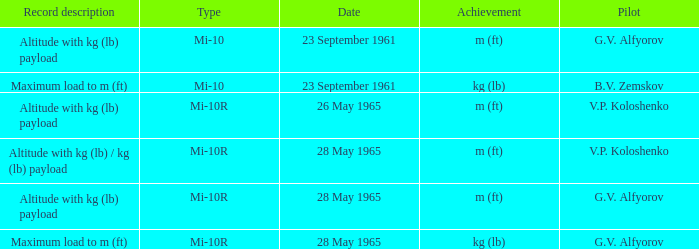Record description of maximum load to m (ft), and a Date of 23 september 1961 is what pilot? B.V. Zemskov. 